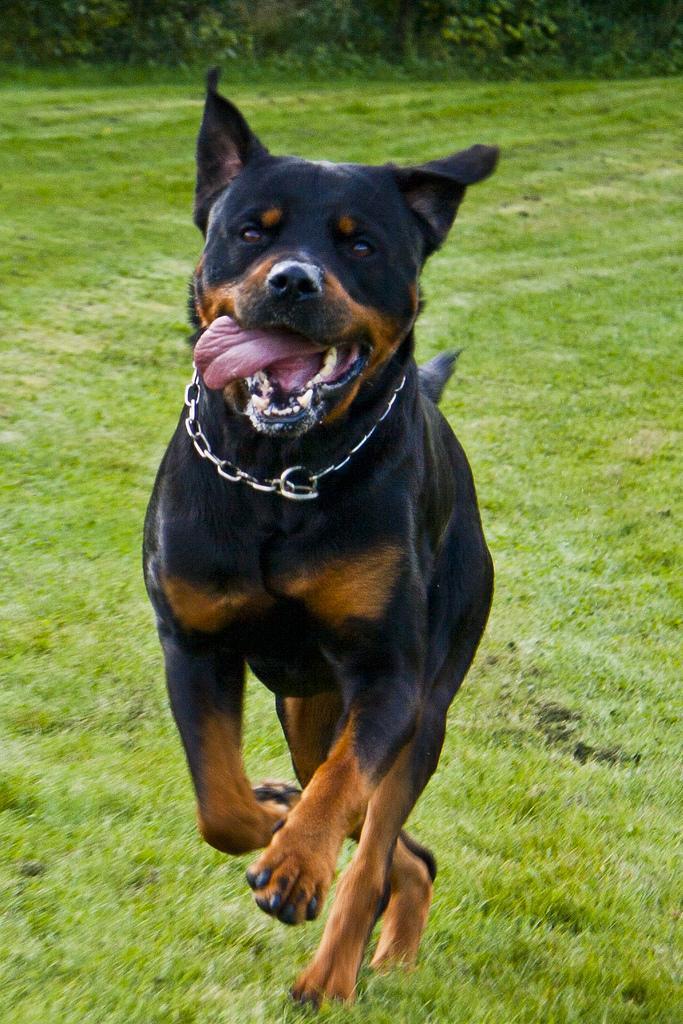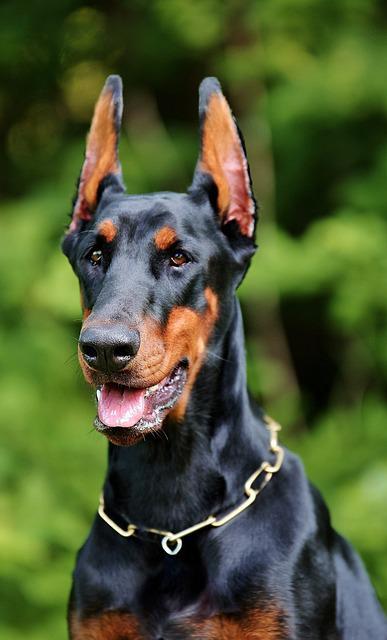The first image is the image on the left, the second image is the image on the right. Given the left and right images, does the statement "One of the dobermans pictures has a black coat and one has a brown coat." hold true? Answer yes or no. No. The first image is the image on the left, the second image is the image on the right. Considering the images on both sides, is "All of the dogs are facing directly to the camera." valid? Answer yes or no. Yes. 